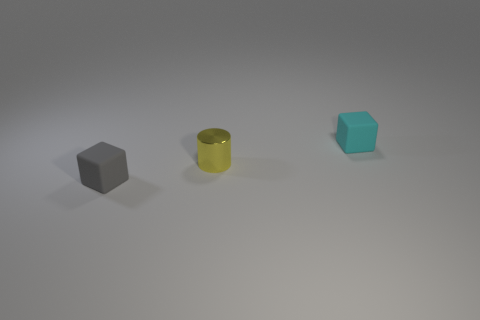Imagining this as a scene from a story, what narrative could you construct around these objects? In a minimalist tale, these objects could be enchanted artifacts each possessing unique properties: the gray cube grants stability, the reflective cylinder contains the power of illumination, and the blue cube holds a drop of the infinite ocean. 